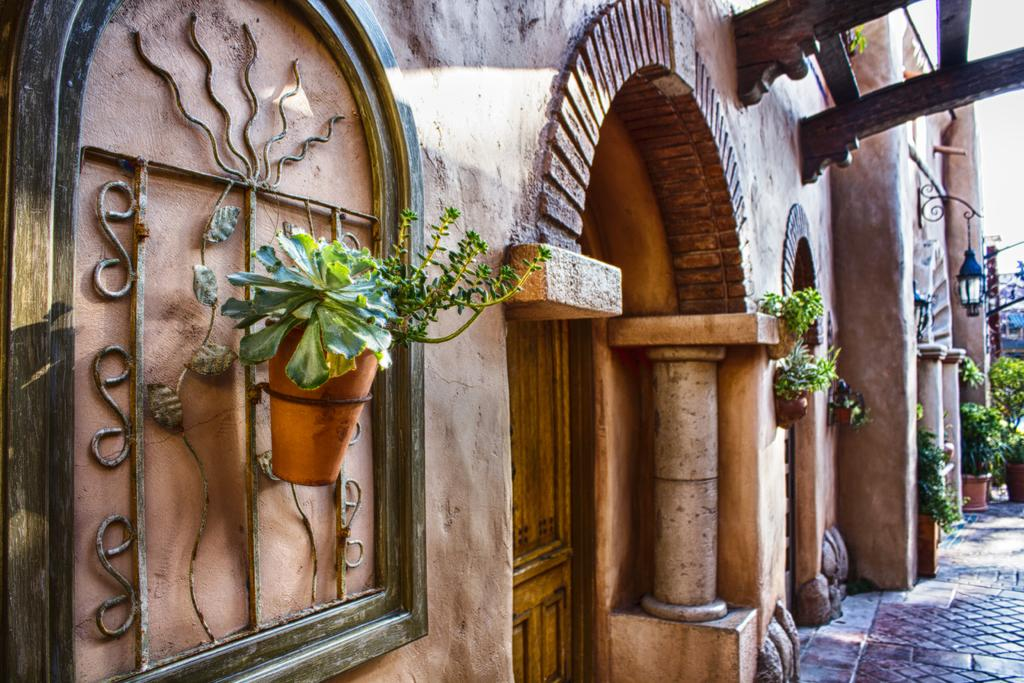What type of structure is visible in the image? There is a building in the image. What architectural feature can be seen in the image? There is an arch construction in the image. What type of object is present for planting purposes? There is a plant pot in the image. What type of lighting fixture is visible in the image? There is a lamp in the image. What is the color of the sky in the image? The sky is white in the image. What type of path is visible in the image? There is a footpath in the image. What suggestion is given by the building in the image? There is no suggestion given by the building in the image. --- Facts: 1. There is a person in the image. 2. The person is wearing a hat. 3. The person is holding a book. 4. The person is standing on a bridge. 5. The bridge is over a river. Absurd Topics: dinosaur, parrot, ocean Conversation: What is the main subject in the image? There is a person in the image. What object is the person holding in their hands? The person is holding a book. Where is the person standing in the image? The person is standing on a bridge. What is the bridge situated over? The bridge is over a river. Reasoning: Let's think step by step in order to produce the conversation. We start by identifying the main subject of the image, which is the person. Next, we describe specific features of the person, such as the hat and the book they are holding. Then, we observe the location of the person, noting that they are standing on a bridge. Finally, we describe the natural setting visible in the image, which is a river. Absurd Question/Answer: What type of dinosaur can be seen swimming in the river in the image? There is no dinosaur present in the image. --- Facts: 1. There is a group of people in the image. 2. The people are sitting around a table. 3. The table is set with plates and utensils. 4. There is a cake in the center of the table. 5. The cake has lit candles on it. Absurd Topics: elephant, monkey, jungle Conversation: How many people are present in the image? There is a group of people in the image. What are the people doing in the image? The people are sitting around a table. What is the purpose of the table being set in the image? The table is set with plates and utensils. What is the main object in the center of the table? There is a cake in the center of the table. 